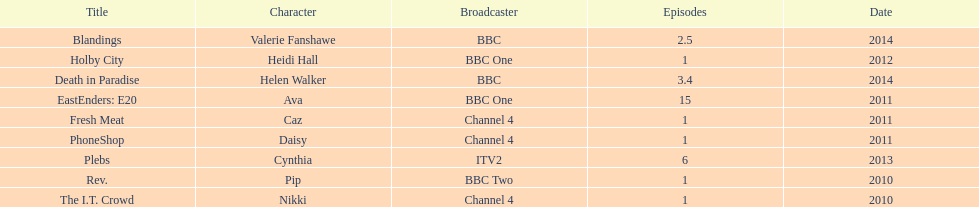Blandings and death in paradise both aired on which broadcaster? BBC. Give me the full table as a dictionary. {'header': ['Title', 'Character', 'Broadcaster', 'Episodes', 'Date'], 'rows': [['Blandings', 'Valerie Fanshawe', 'BBC', '2.5', '2014'], ['Holby City', 'Heidi Hall', 'BBC One', '1', '2012'], ['Death in Paradise', 'Helen Walker', 'BBC', '3.4', '2014'], ['EastEnders: E20', 'Ava', 'BBC One', '15', '2011'], ['Fresh Meat', 'Caz', 'Channel 4', '1', '2011'], ['PhoneShop', 'Daisy', 'Channel 4', '1', '2011'], ['Plebs', 'Cynthia', 'ITV2', '6', '2013'], ['Rev.', 'Pip', 'BBC Two', '1', '2010'], ['The I.T. Crowd', 'Nikki', 'Channel 4', '1', '2010']]} 